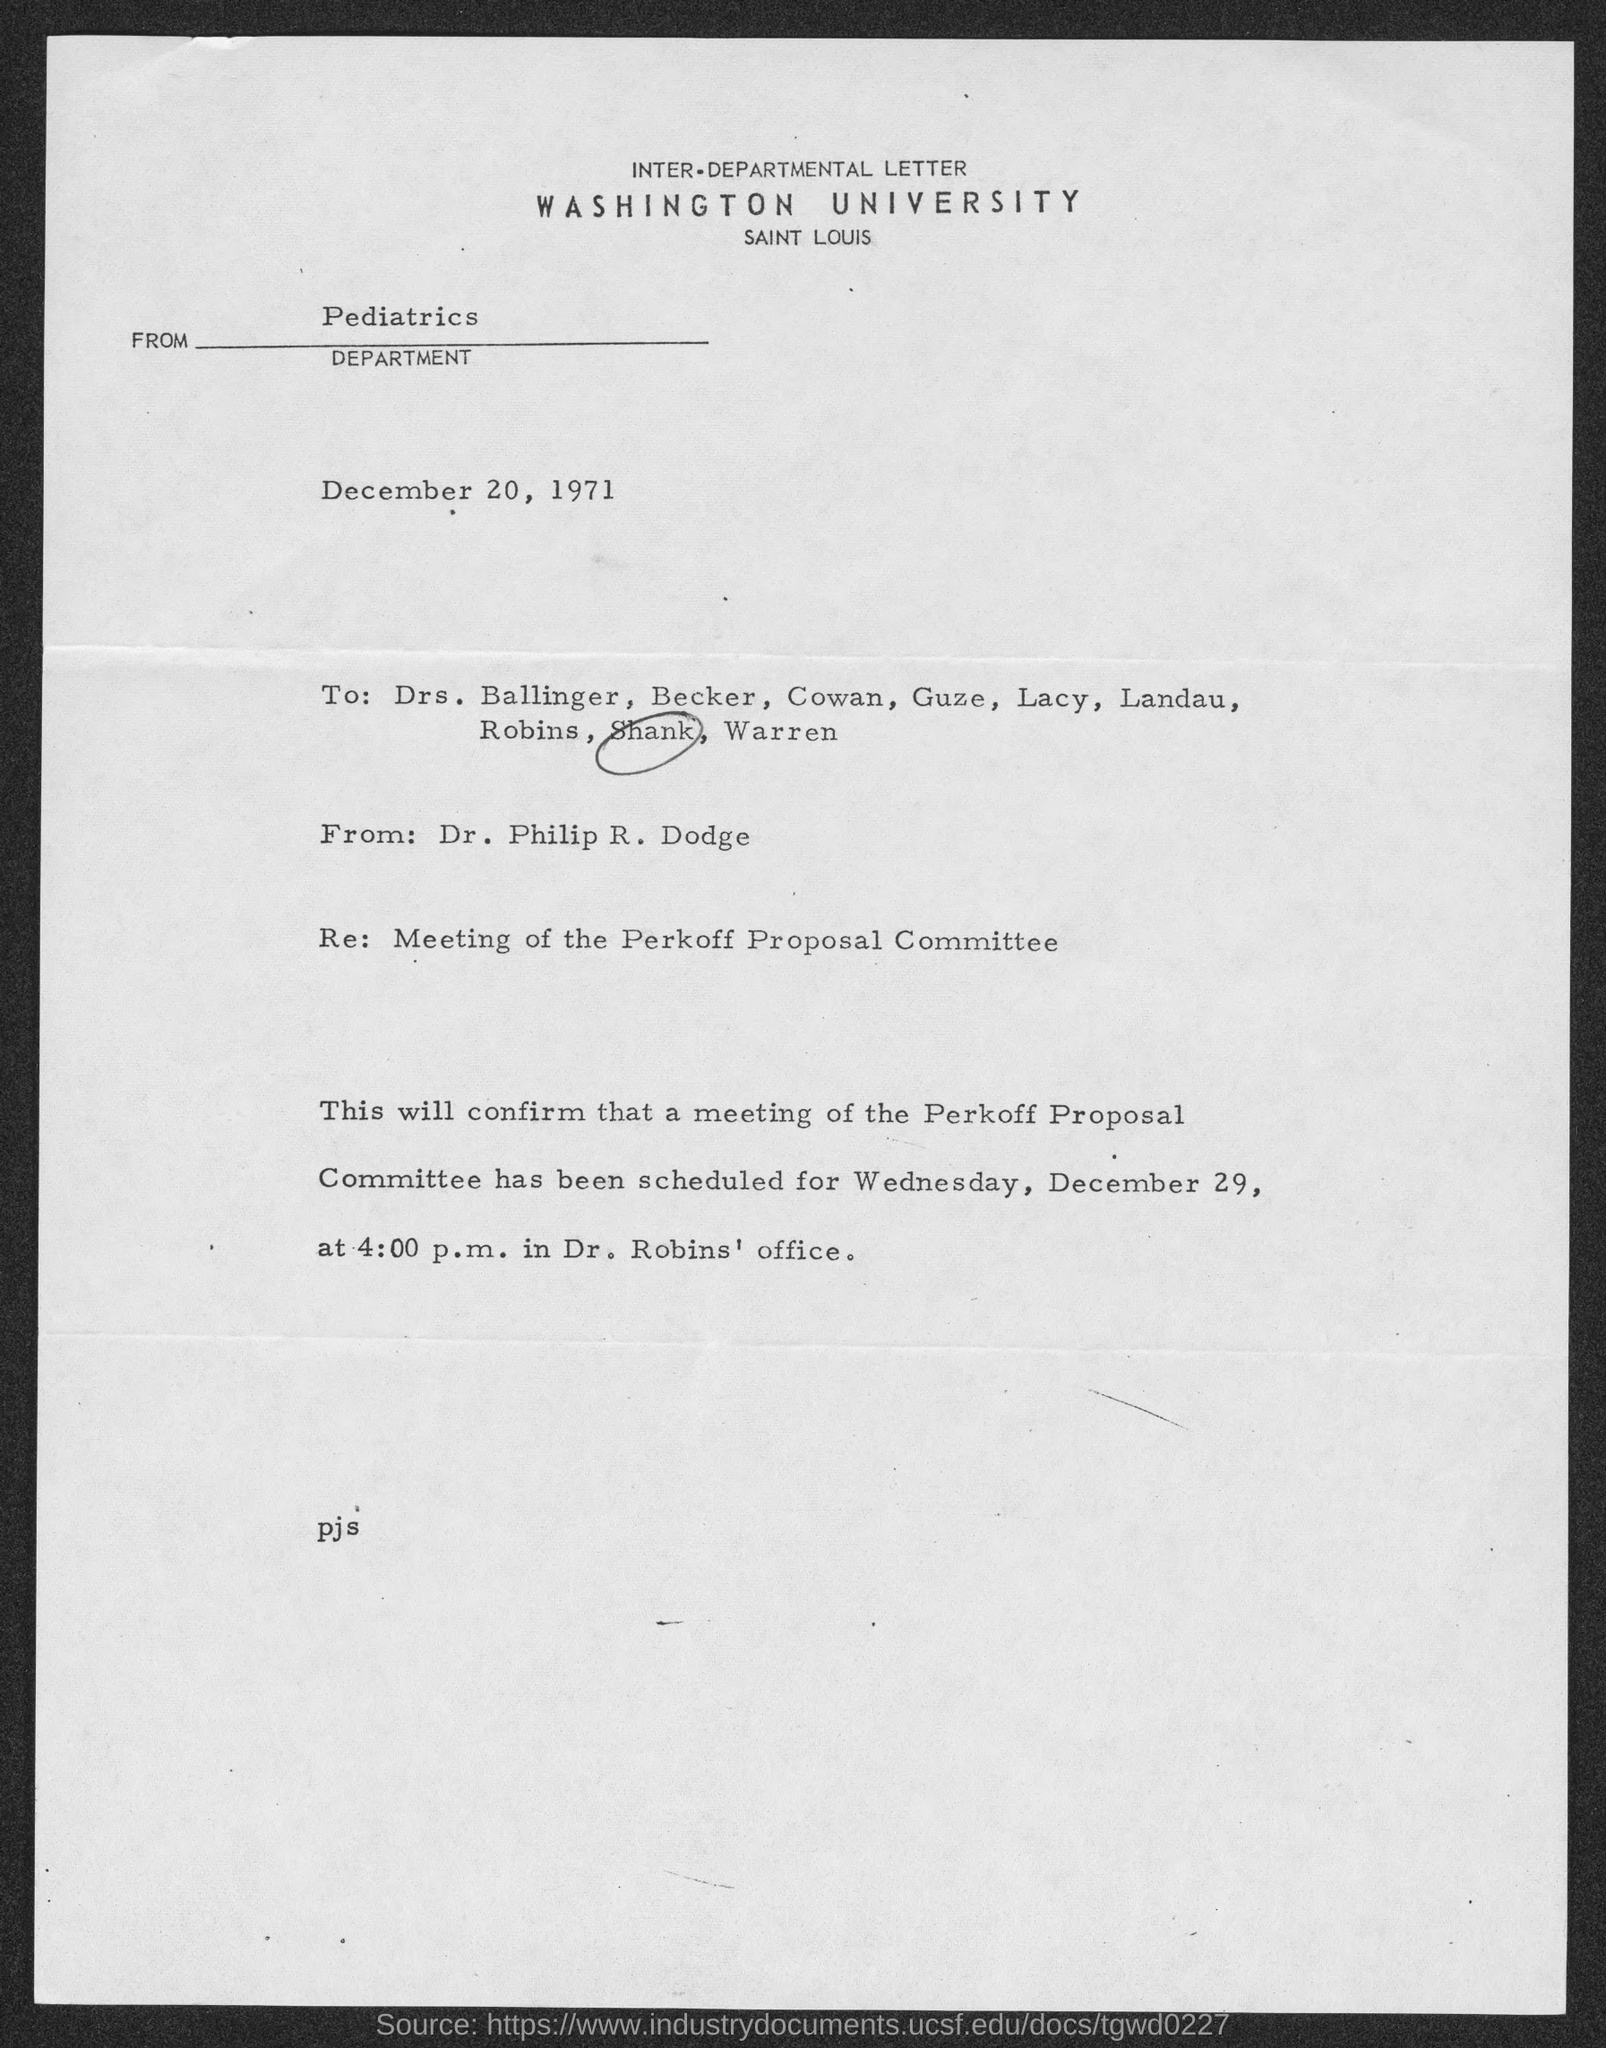Indicate a few pertinent items in this graphic. The address of Washington University is located in Saint Louis. On December 20, 1971, the inter-departmental letter was dated. The Perkoff Proposal Committee has scheduled a meeting for Wednesday. 